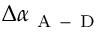<formula> <loc_0><loc_0><loc_500><loc_500>\Delta \alpha _ { A - D }</formula> 